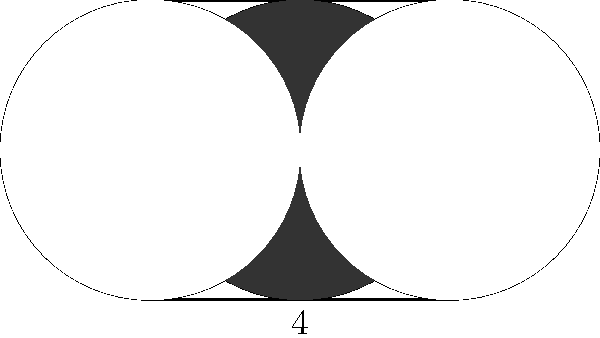In the figure above, a square with side length 4 units contains three circles, each with a radius of 2 units. The centers of the circles are located at the midpoint of the square and at the midpoints of two opposite sides. Calculate the area of the shaded region formed by the overlapping circles within the square. Let's approach this step-by-step:

1) The area of the shaded region is the area of the central circle minus the areas of the two circular segments that overlap with the side circles.

2) Area of the central circle:
   $A_{circle} = \pi r^2 = \pi (2)^2 = 4\pi$ square units

3) To find the area of one circular segment, we need to:
   a) Calculate the area of the sector
   b) Subtract the area of the triangle formed by the center and the chord

4) The central angle of the sector is 60° or $\frac{\pi}{3}$ radians (one-third of the circle).

5) Area of the sector:
   $A_{sector} = \frac{1}{2} r^2 \theta = \frac{1}{2} (2)^2 \frac{\pi}{3} = \frac{2\pi}{3}$ square units

6) Area of the triangle:
   Base of the triangle = $2\sqrt{3}$ (side of an equilateral triangle with radius 2)
   Height of the triangle = 1 (radius minus half of the side length)
   $A_{triangle} = \frac{1}{2} \cdot 2\sqrt{3} \cdot 1 = \sqrt{3}$ square units

7) Area of one circular segment:
   $A_{segment} = A_{sector} - A_{triangle} = \frac{2\pi}{3} - \sqrt{3}$ square units

8) There are two such segments, so the total area to subtract is:
   $2(\frac{2\pi}{3} - \sqrt{3}) = \frac{4\pi}{3} - 2\sqrt{3}$ square units

9) Therefore, the shaded area is:
   $A_{shaded} = 4\pi - (\frac{4\pi}{3} - 2\sqrt{3}) = \frac{8\pi}{3} + 2\sqrt{3}$ square units
Answer: $\frac{8\pi}{3} + 2\sqrt{3}$ square units 